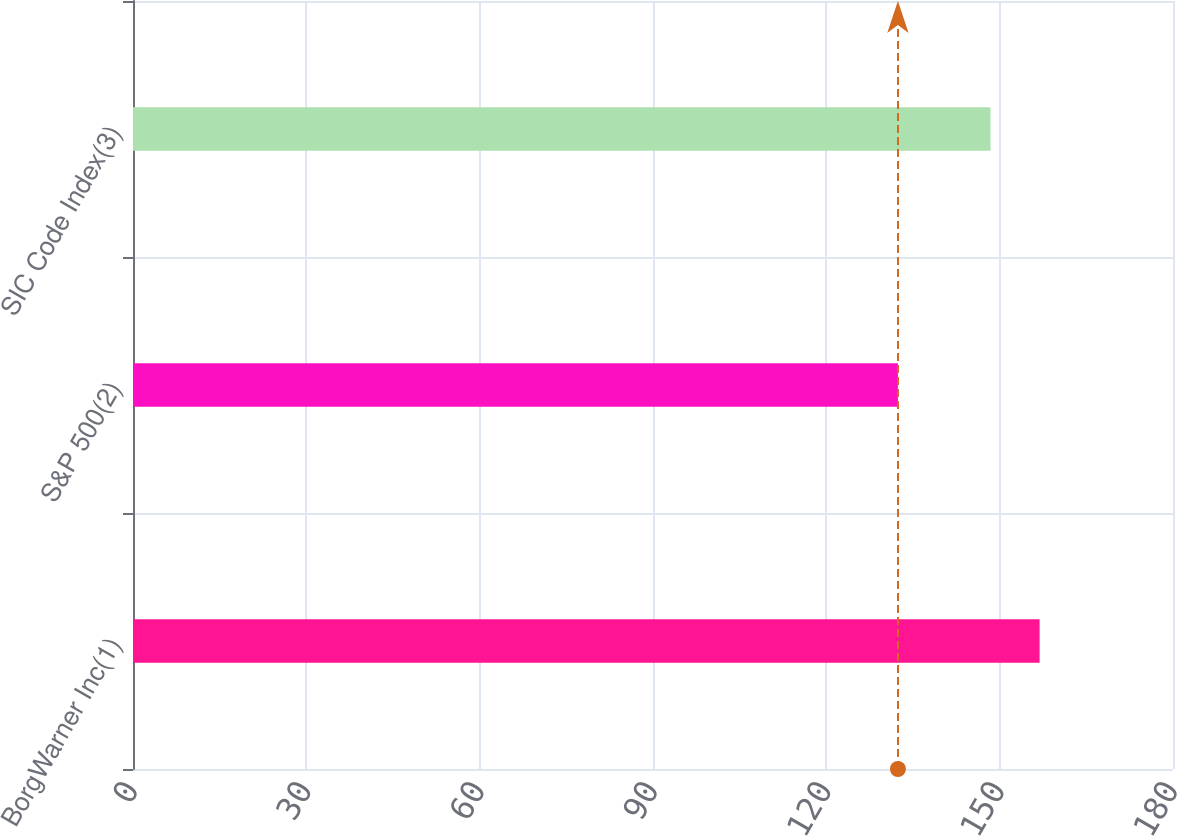<chart> <loc_0><loc_0><loc_500><loc_500><bar_chart><fcel>BorgWarner Inc(1)<fcel>S&P 500(2)<fcel>SIC Code Index(3)<nl><fcel>156.91<fcel>132.39<fcel>148.42<nl></chart> 